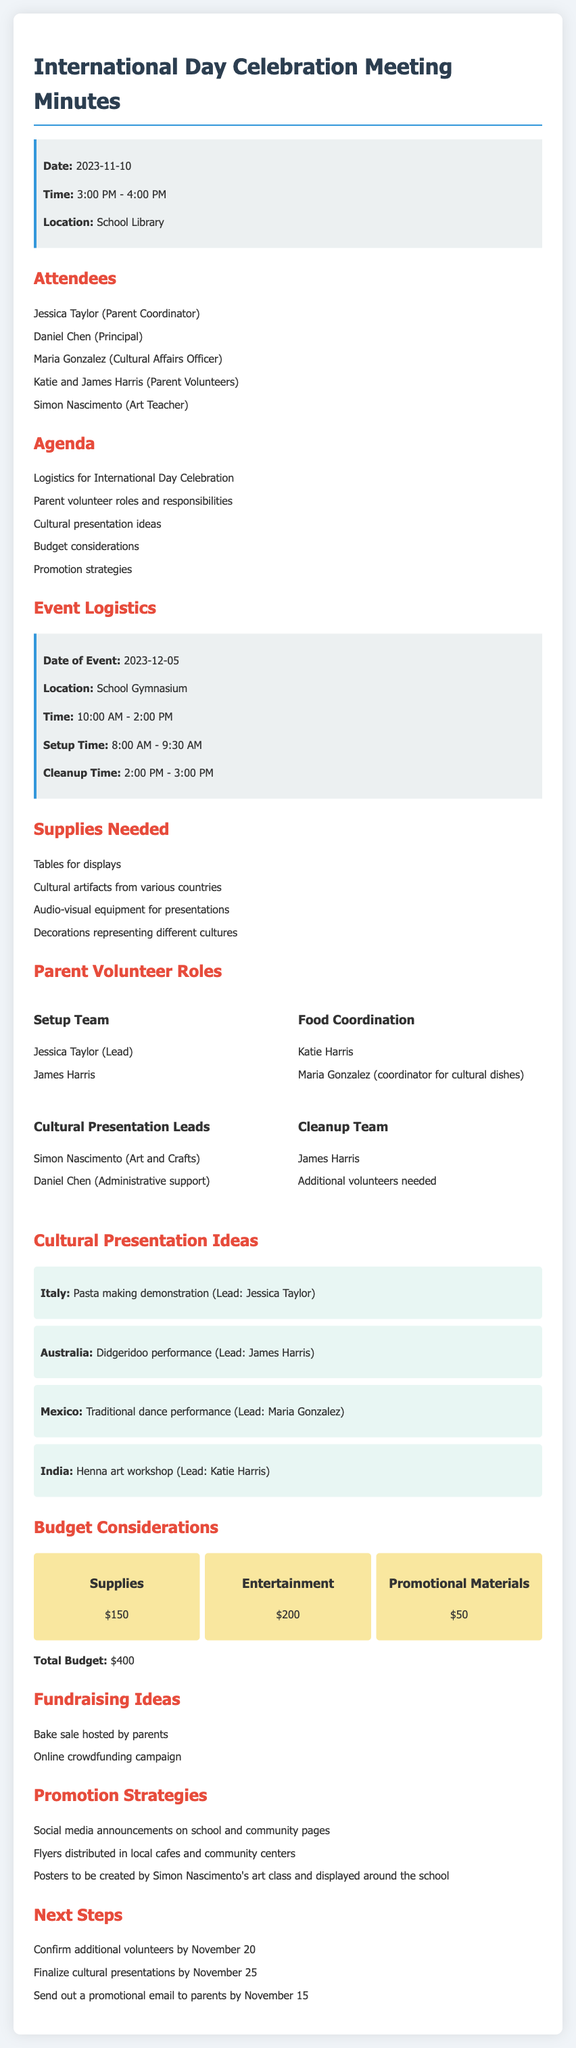what is the date of the event? The date of the event is explicitly mentioned in the document as December 5, 2023.
Answer: December 5, 2023 who is the lead for the Pasta making demonstration? The lead for the Pasta making demonstration is mentioned in the document under Cultural Presentation Ideas.
Answer: Jessica Taylor when is the setup time for the event? The document specifies the setup time as 8:00 AM to 9:30 AM.
Answer: 8:00 AM - 9:30 AM what is the total budget for the event? The total budget is provided in the Budget Considerations section.
Answer: $400 who is responsible for food coordination? This role is outlined in the Parent Volunteer Roles section, indicating who will handle food coordination.
Answer: Katie Harris and Maria Gonzalez what are the two fundraising ideas mentioned? Fundraising ideas can be found towards the end of the document, highlighting ways to raise funds for the event.
Answer: Bake sale and online crowdfunding campaign how many cultural presentations are planned? The document lists specific cultural presentations, providing a count of the planned activities.
Answer: Four what is the cleanup time for the event? The cleanup time is detailed in the Event Logistics section, indicating when cleanup will occur.
Answer: 2:00 PM - 3:00 PM what is the main purpose of the meeting? The agenda outlines the main aspects discussed, indicating what the meeting aimed to achieve.
Answer: Planning the International Day Celebration 